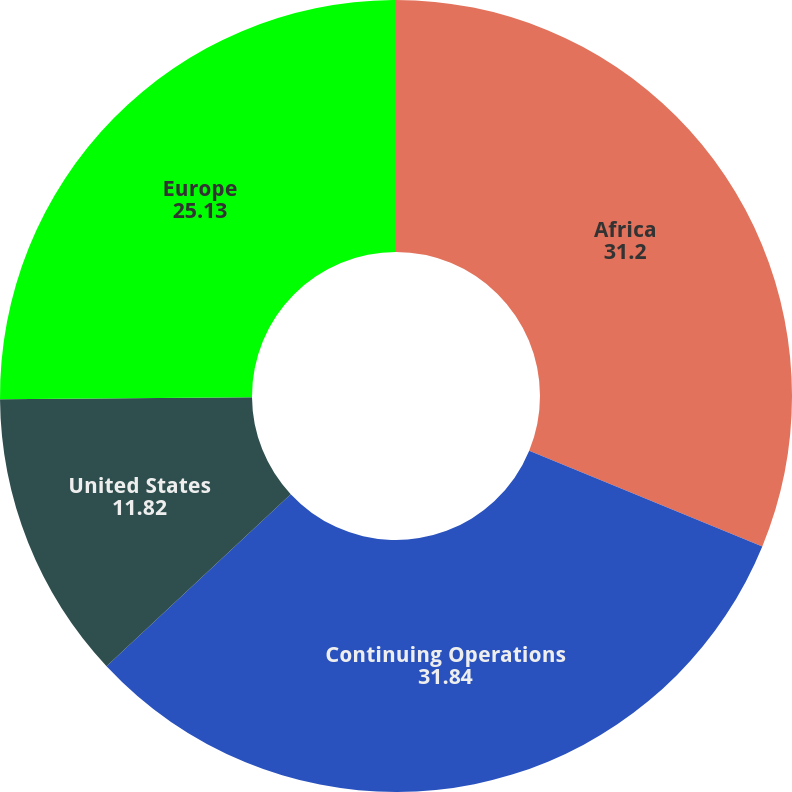Convert chart to OTSL. <chart><loc_0><loc_0><loc_500><loc_500><pie_chart><fcel>Africa<fcel>Continuing Operations<fcel>United States<fcel>Europe<nl><fcel>31.2%<fcel>31.84%<fcel>11.82%<fcel>25.13%<nl></chart> 